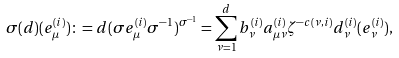Convert formula to latex. <formula><loc_0><loc_0><loc_500><loc_500>\sigma ( d ) ( e _ { \mu } ^ { ( i ) } ) \colon = d ( \sigma e _ { \mu } ^ { ( i ) } \sigma ^ { - 1 } ) ^ { \sigma ^ { - 1 } } = \sum _ { \nu = 1 } ^ { d } b _ { \nu } ^ { ( i ) } a _ { \mu \nu } ^ { ( i ) } \zeta ^ { - c ( \nu , i ) } d _ { \nu } ^ { ( i ) } ( e _ { \nu } ^ { ( i ) } ) ,</formula> 